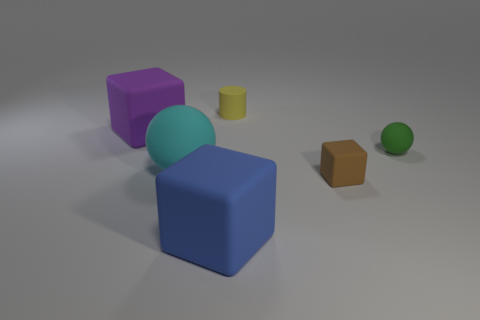Add 3 tiny yellow objects. How many objects exist? 9 Subtract all spheres. How many objects are left? 4 Subtract 0 red cubes. How many objects are left? 6 Subtract all big spheres. Subtract all tiny green matte things. How many objects are left? 4 Add 4 green objects. How many green objects are left? 5 Add 1 green matte spheres. How many green matte spheres exist? 2 